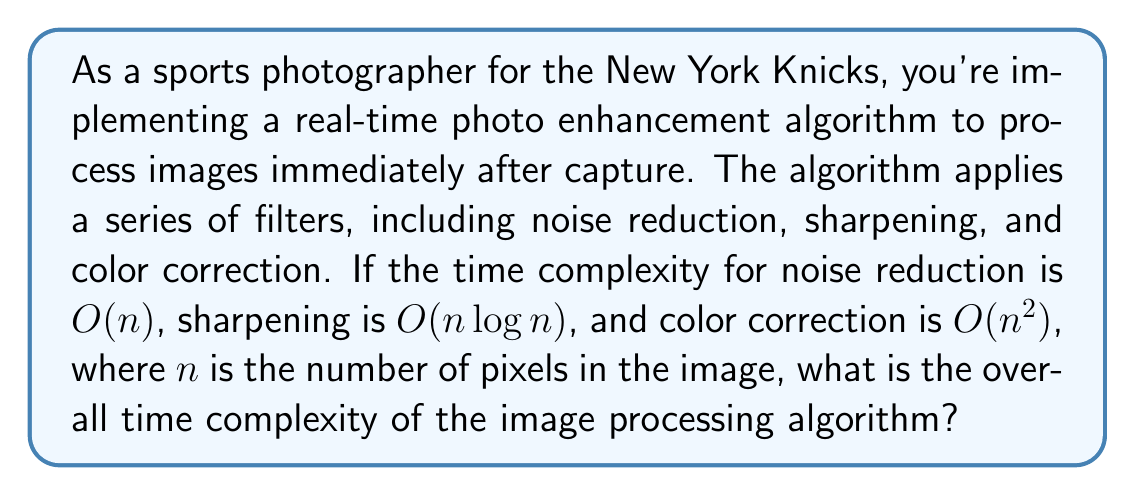What is the answer to this math problem? To determine the overall time complexity of the image processing algorithm, we need to analyze the individual components and combine them according to the rules of time complexity analysis:

1. Noise reduction: $O(n)$
2. Sharpening: $O(n \log n)$
3. Color correction: $O(n^2)$

When algorithms are executed sequentially, we add their time complexities. However, we only keep the term with the highest order of growth. This is because as $n$ becomes very large, the term with the highest order of growth dominates the overall time complexity.

In this case, we have:

$$O(n) + O(n \log n) + O(n^2)$$

Comparing the growth rates:

- $O(n)$ grows linearly
- $O(n \log n)$ grows slightly faster than linear
- $O(n^2)$ grows quadratically

Since $n^2$ grows faster than both $n$ and $n \log n$ for large values of $n$, it dominates the overall time complexity.

Therefore, the overall time complexity of the image processing algorithm is $O(n^2)$.
Answer: $O(n^2)$ 